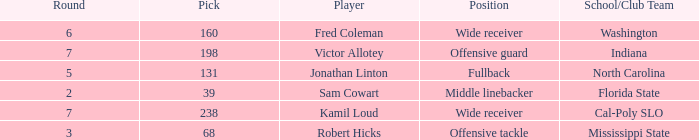Which Player has a Round smaller than 5, and a School/Club Team of florida state? Sam Cowart. 